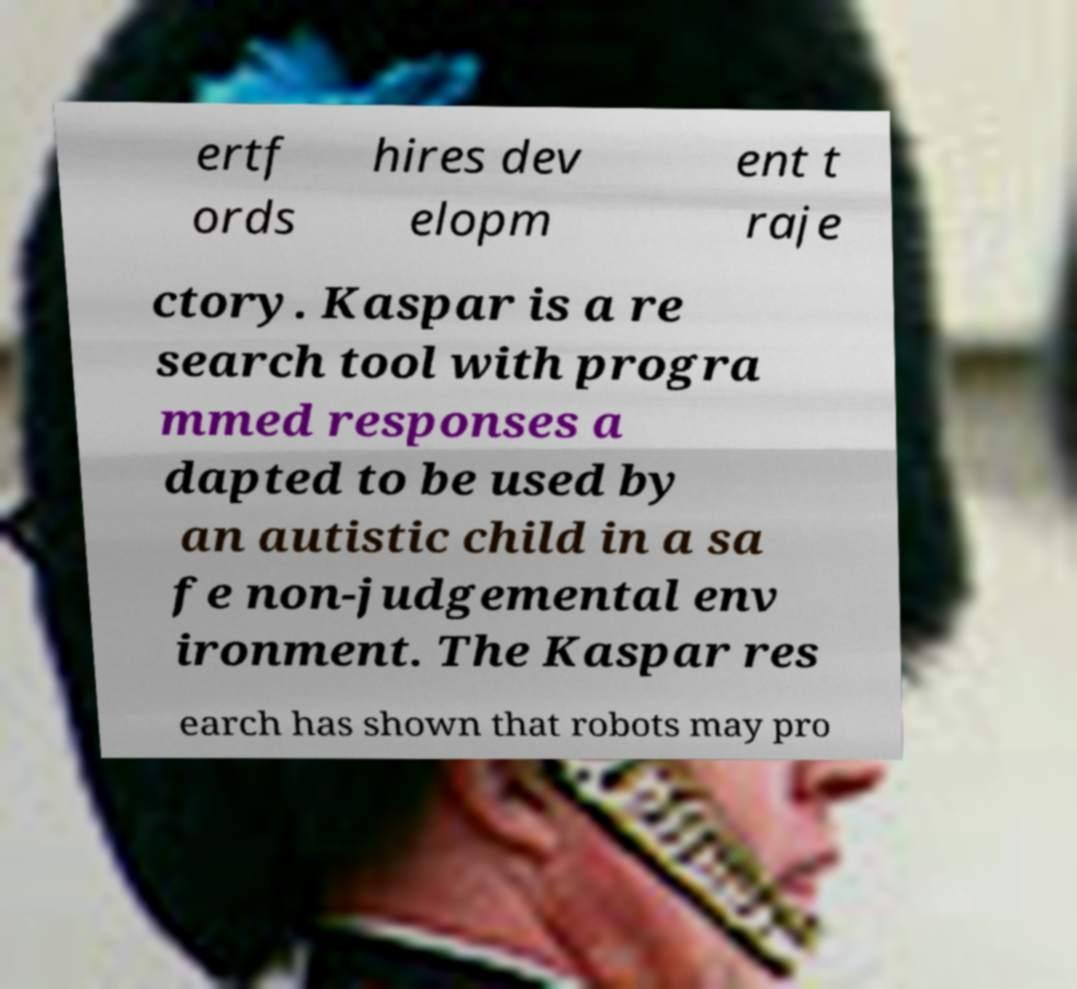For documentation purposes, I need the text within this image transcribed. Could you provide that? ertf ords hires dev elopm ent t raje ctory. Kaspar is a re search tool with progra mmed responses a dapted to be used by an autistic child in a sa fe non-judgemental env ironment. The Kaspar res earch has shown that robots may pro 